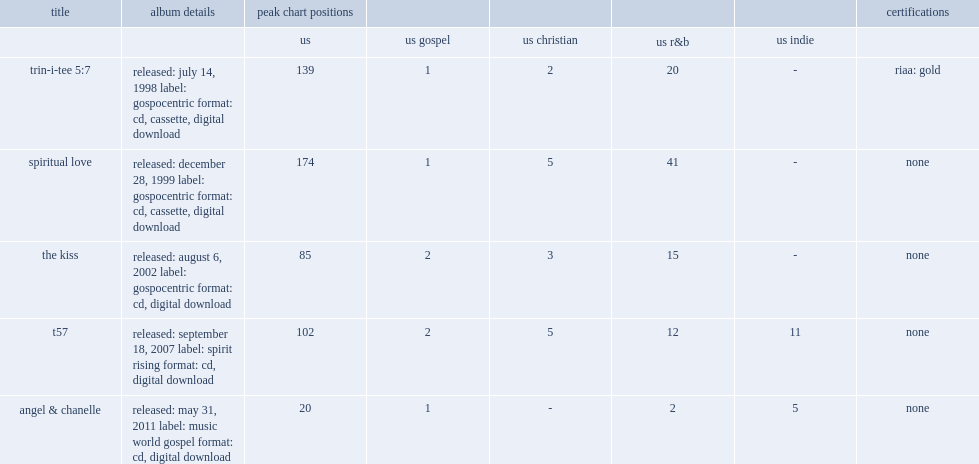What was the peak chart position on the us of trin-i-tee 5:7 ? 139.0. 